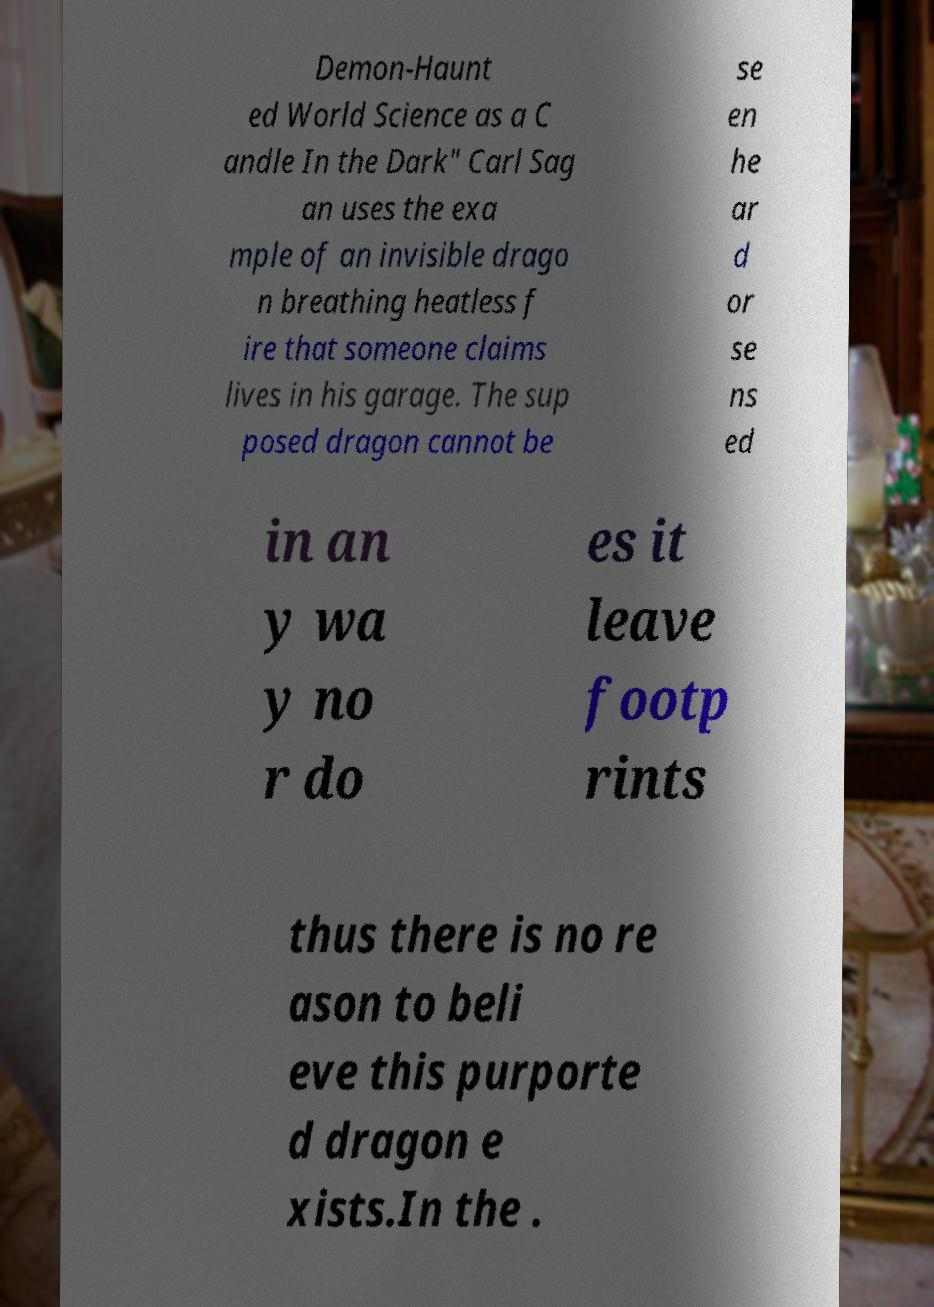Can you read and provide the text displayed in the image?This photo seems to have some interesting text. Can you extract and type it out for me? Demon-Haunt ed World Science as a C andle In the Dark" Carl Sag an uses the exa mple of an invisible drago n breathing heatless f ire that someone claims lives in his garage. The sup posed dragon cannot be se en he ar d or se ns ed in an y wa y no r do es it leave footp rints thus there is no re ason to beli eve this purporte d dragon e xists.In the . 